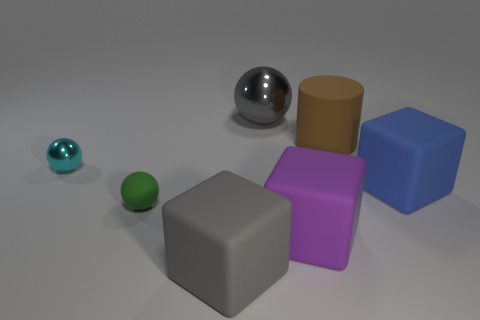Add 1 large blocks. How many objects exist? 8 Subtract all green rubber spheres. How many spheres are left? 2 Subtract 1 balls. How many balls are left? 2 Subtract all cylinders. How many objects are left? 6 Subtract all blue spheres. Subtract all cyan cylinders. How many spheres are left? 3 Subtract all brown rubber cylinders. Subtract all tiny green balls. How many objects are left? 5 Add 6 large blue cubes. How many large blue cubes are left? 7 Add 7 gray objects. How many gray objects exist? 9 Subtract 0 red cylinders. How many objects are left? 7 